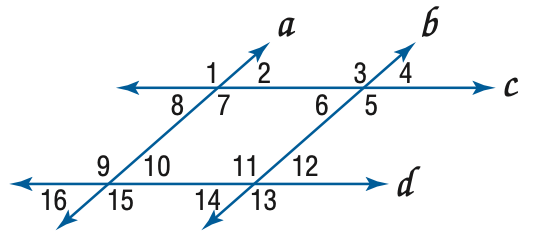Answer the mathemtical geometry problem and directly provide the correct option letter.
Question: In the figure, a \parallel b, c \parallel d, and m \angle 4 = 57. Find the measure of \angle 8.
Choices: A: 57 B: 113 C: 123 D: 133 A 